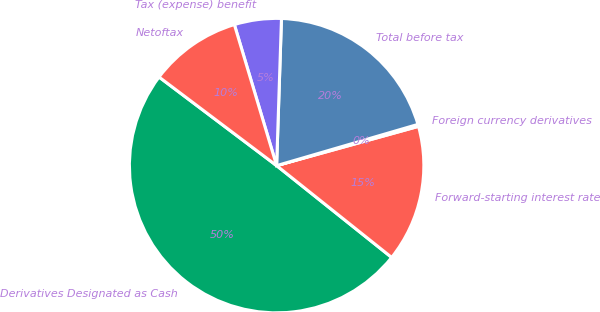Convert chart to OTSL. <chart><loc_0><loc_0><loc_500><loc_500><pie_chart><fcel>Derivatives Designated as Cash<fcel>Forward-starting interest rate<fcel>Foreign currency derivatives<fcel>Total before tax<fcel>Tax (expense) benefit<fcel>Netoftax<nl><fcel>49.56%<fcel>15.02%<fcel>0.22%<fcel>19.96%<fcel>5.16%<fcel>10.09%<nl></chart> 